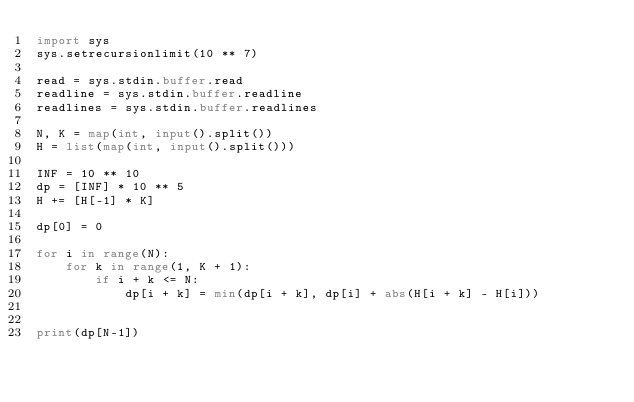<code> <loc_0><loc_0><loc_500><loc_500><_Python_>import sys
sys.setrecursionlimit(10 ** 7)

read = sys.stdin.buffer.read
readline = sys.stdin.buffer.readline
readlines = sys.stdin.buffer.readlines

N, K = map(int, input().split())
H = list(map(int, input().split()))

INF = 10 ** 10
dp = [INF] * 10 ** 5
H += [H[-1] * K]

dp[0] = 0

for i in range(N):
    for k in range(1, K + 1):
        if i + k <= N:
            dp[i + k] = min(dp[i + k], dp[i] + abs(H[i + k] - H[i]))


print(dp[N-1])
</code> 